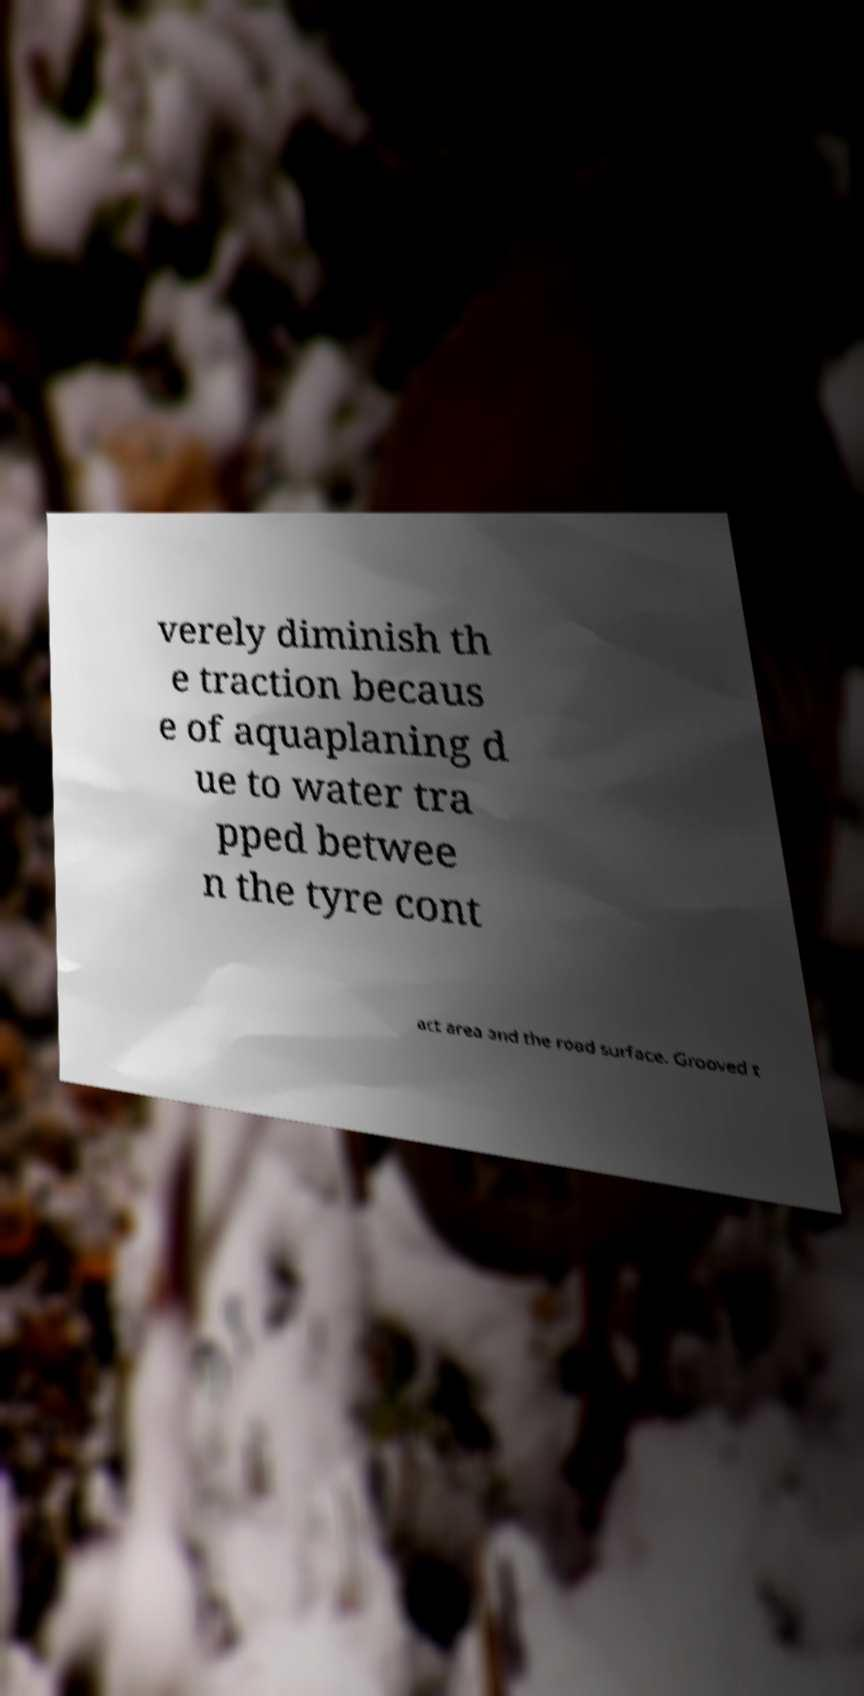There's text embedded in this image that I need extracted. Can you transcribe it verbatim? verely diminish th e traction becaus e of aquaplaning d ue to water tra pped betwee n the tyre cont act area and the road surface. Grooved t 